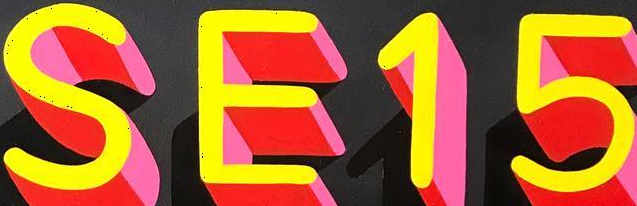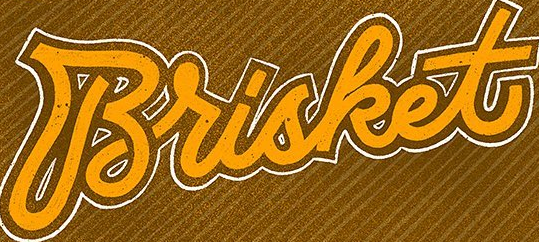Identify the words shown in these images in order, separated by a semicolon. SE15; Brisket 